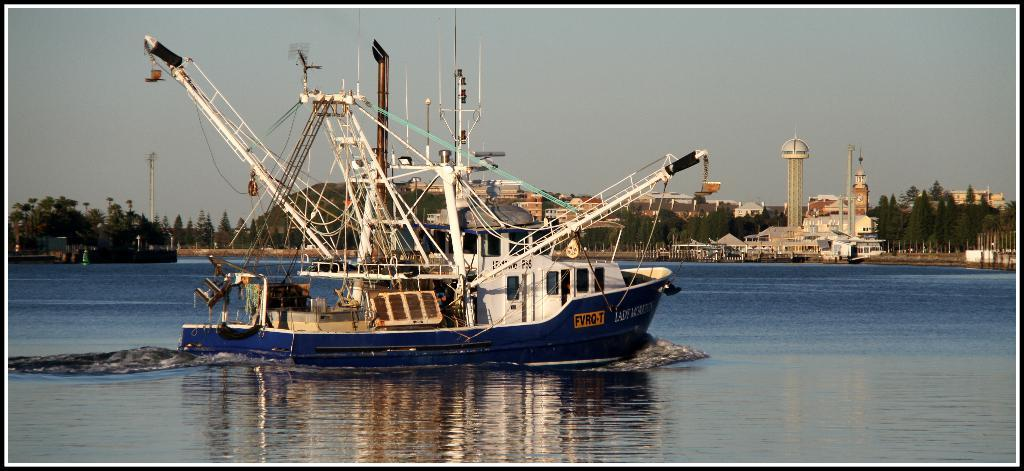What is the main subject of the image? The main subject of the image is a ship. Where is the ship located in the image? The ship is on a river. What can be seen in the background of the image? There are buildings, trees, and the sky visible in the background of the image. What type of authority figure can be seen holding a gun in the image? There is no authority figure or gun present in the image; it features a ship on a river with buildings, trees, and the sky in the background. 